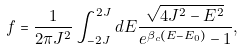<formula> <loc_0><loc_0><loc_500><loc_500>f = \frac { 1 } { 2 \pi J ^ { 2 } } \int _ { - 2 J } ^ { 2 J } d E \frac { \sqrt { 4 J ^ { 2 } - E ^ { 2 } } } { e ^ { \beta _ { c } ( E - E _ { 0 } ) } - 1 } ,</formula> 